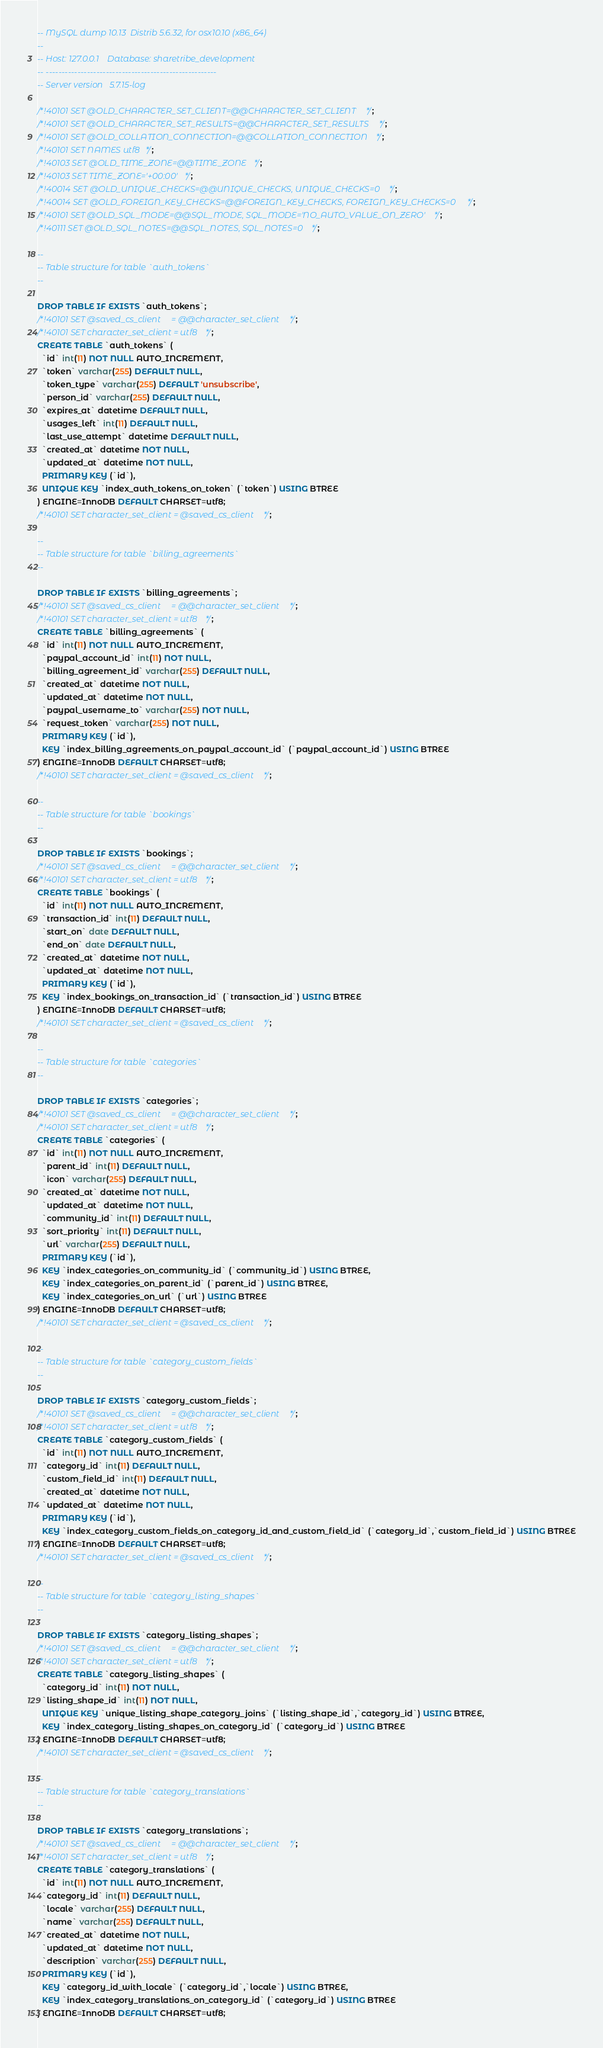Convert code to text. <code><loc_0><loc_0><loc_500><loc_500><_SQL_>-- MySQL dump 10.13  Distrib 5.6.32, for osx10.10 (x86_64)
--
-- Host: 127.0.0.1    Database: sharetribe_development
-- ------------------------------------------------------
-- Server version	5.7.15-log

/*!40101 SET @OLD_CHARACTER_SET_CLIENT=@@CHARACTER_SET_CLIENT */;
/*!40101 SET @OLD_CHARACTER_SET_RESULTS=@@CHARACTER_SET_RESULTS */;
/*!40101 SET @OLD_COLLATION_CONNECTION=@@COLLATION_CONNECTION */;
/*!40101 SET NAMES utf8 */;
/*!40103 SET @OLD_TIME_ZONE=@@TIME_ZONE */;
/*!40103 SET TIME_ZONE='+00:00' */;
/*!40014 SET @OLD_UNIQUE_CHECKS=@@UNIQUE_CHECKS, UNIQUE_CHECKS=0 */;
/*!40014 SET @OLD_FOREIGN_KEY_CHECKS=@@FOREIGN_KEY_CHECKS, FOREIGN_KEY_CHECKS=0 */;
/*!40101 SET @OLD_SQL_MODE=@@SQL_MODE, SQL_MODE='NO_AUTO_VALUE_ON_ZERO' */;
/*!40111 SET @OLD_SQL_NOTES=@@SQL_NOTES, SQL_NOTES=0 */;

--
-- Table structure for table `auth_tokens`
--

DROP TABLE IF EXISTS `auth_tokens`;
/*!40101 SET @saved_cs_client     = @@character_set_client */;
/*!40101 SET character_set_client = utf8 */;
CREATE TABLE `auth_tokens` (
  `id` int(11) NOT NULL AUTO_INCREMENT,
  `token` varchar(255) DEFAULT NULL,
  `token_type` varchar(255) DEFAULT 'unsubscribe',
  `person_id` varchar(255) DEFAULT NULL,
  `expires_at` datetime DEFAULT NULL,
  `usages_left` int(11) DEFAULT NULL,
  `last_use_attempt` datetime DEFAULT NULL,
  `created_at` datetime NOT NULL,
  `updated_at` datetime NOT NULL,
  PRIMARY KEY (`id`),
  UNIQUE KEY `index_auth_tokens_on_token` (`token`) USING BTREE
) ENGINE=InnoDB DEFAULT CHARSET=utf8;
/*!40101 SET character_set_client = @saved_cs_client */;

--
-- Table structure for table `billing_agreements`
--

DROP TABLE IF EXISTS `billing_agreements`;
/*!40101 SET @saved_cs_client     = @@character_set_client */;
/*!40101 SET character_set_client = utf8 */;
CREATE TABLE `billing_agreements` (
  `id` int(11) NOT NULL AUTO_INCREMENT,
  `paypal_account_id` int(11) NOT NULL,
  `billing_agreement_id` varchar(255) DEFAULT NULL,
  `created_at` datetime NOT NULL,
  `updated_at` datetime NOT NULL,
  `paypal_username_to` varchar(255) NOT NULL,
  `request_token` varchar(255) NOT NULL,
  PRIMARY KEY (`id`),
  KEY `index_billing_agreements_on_paypal_account_id` (`paypal_account_id`) USING BTREE
) ENGINE=InnoDB DEFAULT CHARSET=utf8;
/*!40101 SET character_set_client = @saved_cs_client */;

--
-- Table structure for table `bookings`
--

DROP TABLE IF EXISTS `bookings`;
/*!40101 SET @saved_cs_client     = @@character_set_client */;
/*!40101 SET character_set_client = utf8 */;
CREATE TABLE `bookings` (
  `id` int(11) NOT NULL AUTO_INCREMENT,
  `transaction_id` int(11) DEFAULT NULL,
  `start_on` date DEFAULT NULL,
  `end_on` date DEFAULT NULL,
  `created_at` datetime NOT NULL,
  `updated_at` datetime NOT NULL,
  PRIMARY KEY (`id`),
  KEY `index_bookings_on_transaction_id` (`transaction_id`) USING BTREE
) ENGINE=InnoDB DEFAULT CHARSET=utf8;
/*!40101 SET character_set_client = @saved_cs_client */;

--
-- Table structure for table `categories`
--

DROP TABLE IF EXISTS `categories`;
/*!40101 SET @saved_cs_client     = @@character_set_client */;
/*!40101 SET character_set_client = utf8 */;
CREATE TABLE `categories` (
  `id` int(11) NOT NULL AUTO_INCREMENT,
  `parent_id` int(11) DEFAULT NULL,
  `icon` varchar(255) DEFAULT NULL,
  `created_at` datetime NOT NULL,
  `updated_at` datetime NOT NULL,
  `community_id` int(11) DEFAULT NULL,
  `sort_priority` int(11) DEFAULT NULL,
  `url` varchar(255) DEFAULT NULL,
  PRIMARY KEY (`id`),
  KEY `index_categories_on_community_id` (`community_id`) USING BTREE,
  KEY `index_categories_on_parent_id` (`parent_id`) USING BTREE,
  KEY `index_categories_on_url` (`url`) USING BTREE
) ENGINE=InnoDB DEFAULT CHARSET=utf8;
/*!40101 SET character_set_client = @saved_cs_client */;

--
-- Table structure for table `category_custom_fields`
--

DROP TABLE IF EXISTS `category_custom_fields`;
/*!40101 SET @saved_cs_client     = @@character_set_client */;
/*!40101 SET character_set_client = utf8 */;
CREATE TABLE `category_custom_fields` (
  `id` int(11) NOT NULL AUTO_INCREMENT,
  `category_id` int(11) DEFAULT NULL,
  `custom_field_id` int(11) DEFAULT NULL,
  `created_at` datetime NOT NULL,
  `updated_at` datetime NOT NULL,
  PRIMARY KEY (`id`),
  KEY `index_category_custom_fields_on_category_id_and_custom_field_id` (`category_id`,`custom_field_id`) USING BTREE
) ENGINE=InnoDB DEFAULT CHARSET=utf8;
/*!40101 SET character_set_client = @saved_cs_client */;

--
-- Table structure for table `category_listing_shapes`
--

DROP TABLE IF EXISTS `category_listing_shapes`;
/*!40101 SET @saved_cs_client     = @@character_set_client */;
/*!40101 SET character_set_client = utf8 */;
CREATE TABLE `category_listing_shapes` (
  `category_id` int(11) NOT NULL,
  `listing_shape_id` int(11) NOT NULL,
  UNIQUE KEY `unique_listing_shape_category_joins` (`listing_shape_id`,`category_id`) USING BTREE,
  KEY `index_category_listing_shapes_on_category_id` (`category_id`) USING BTREE
) ENGINE=InnoDB DEFAULT CHARSET=utf8;
/*!40101 SET character_set_client = @saved_cs_client */;

--
-- Table structure for table `category_translations`
--

DROP TABLE IF EXISTS `category_translations`;
/*!40101 SET @saved_cs_client     = @@character_set_client */;
/*!40101 SET character_set_client = utf8 */;
CREATE TABLE `category_translations` (
  `id` int(11) NOT NULL AUTO_INCREMENT,
  `category_id` int(11) DEFAULT NULL,
  `locale` varchar(255) DEFAULT NULL,
  `name` varchar(255) DEFAULT NULL,
  `created_at` datetime NOT NULL,
  `updated_at` datetime NOT NULL,
  `description` varchar(255) DEFAULT NULL,
  PRIMARY KEY (`id`),
  KEY `category_id_with_locale` (`category_id`,`locale`) USING BTREE,
  KEY `index_category_translations_on_category_id` (`category_id`) USING BTREE
) ENGINE=InnoDB DEFAULT CHARSET=utf8;</code> 